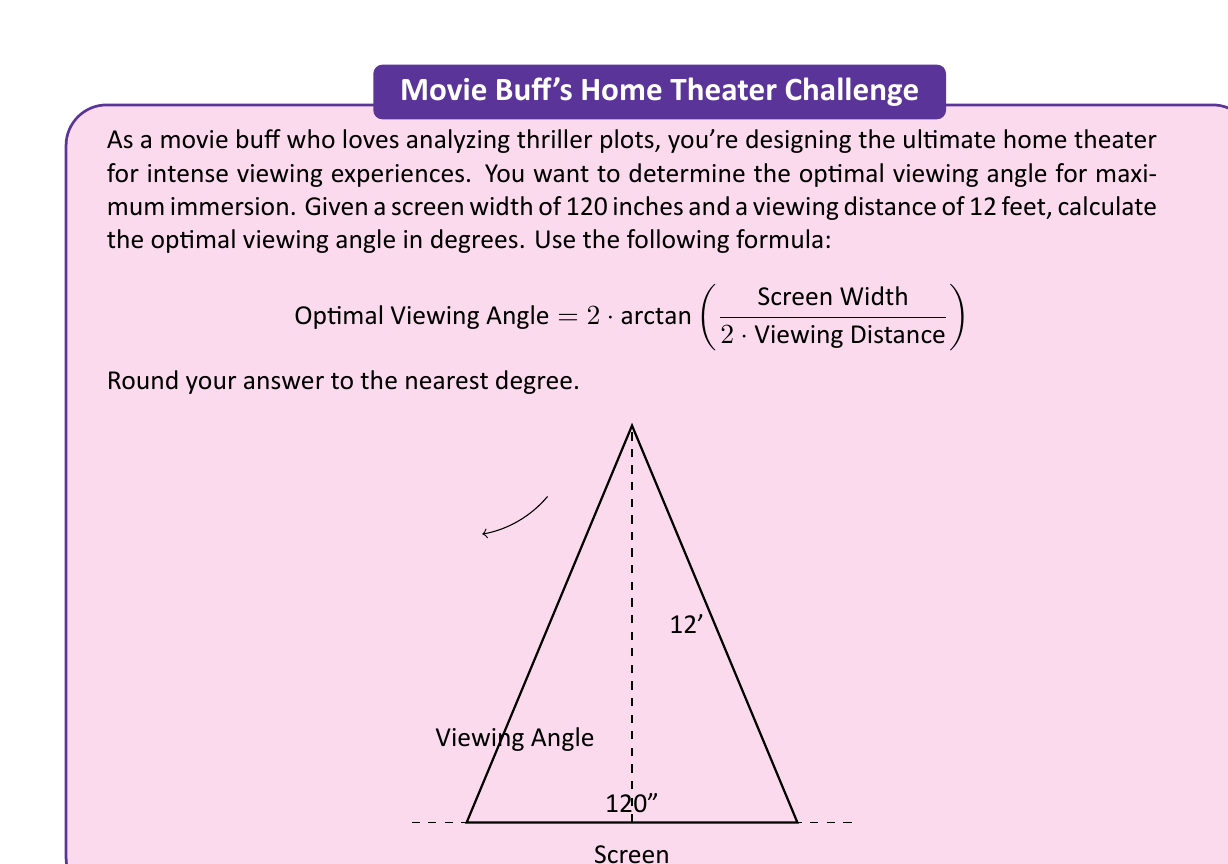Show me your answer to this math problem. To solve this problem, we'll follow these steps:

1) First, let's convert all measurements to the same unit. The screen width is given in inches, but the viewing distance is in feet. Let's convert the viewing distance to inches:
   $12 \text{ feet} = 12 \cdot 12 = 144 \text{ inches}$

2) Now we can plug our values into the formula:
   $$ \text{Optimal Viewing Angle} = 2 \cdot \arctan\left(\frac{120}{2 \cdot 144}\right) $$

3) Simplify inside the parentheses:
   $$ = 2 \cdot \arctan\left(\frac{120}{288}\right) = 2 \cdot \arctan\left(\frac{5}{12}\right) $$

4) Calculate the arctangent:
   $$ = 2 \cdot 0.3947... $$

5) Multiply:
   $$ = 0.7894... $$

6) Convert from radians to degrees:
   $$ = 0.7894... \cdot \frac{180}{\pi} = 45.24... \text{ degrees} $$

7) Rounding to the nearest degree:
   $45 \text{ degrees}$

This optimal viewing angle ensures that the screen fills a significant portion of your field of view, enhancing the immersive experience for those thrilling plot twists!
Answer: $45 \text{ degrees}$ 